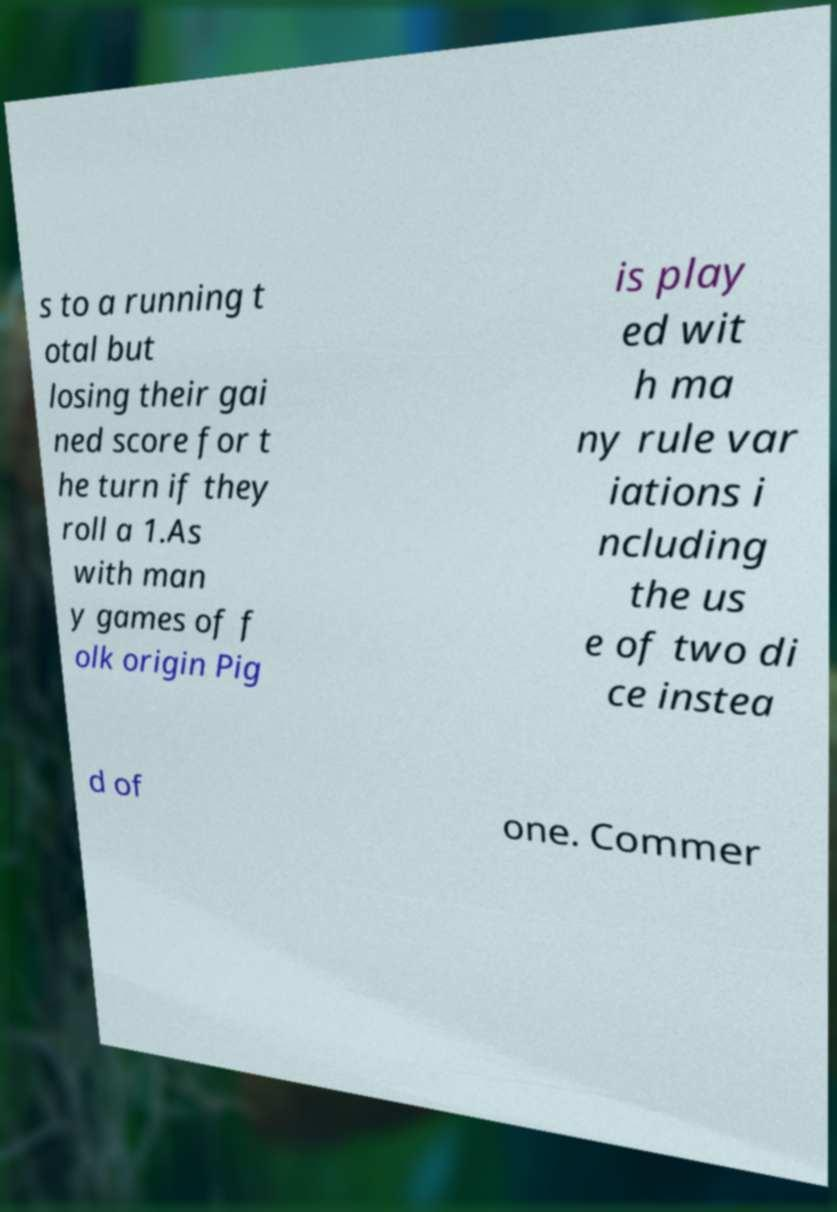Can you read and provide the text displayed in the image?This photo seems to have some interesting text. Can you extract and type it out for me? s to a running t otal but losing their gai ned score for t he turn if they roll a 1.As with man y games of f olk origin Pig is play ed wit h ma ny rule var iations i ncluding the us e of two di ce instea d of one. Commer 